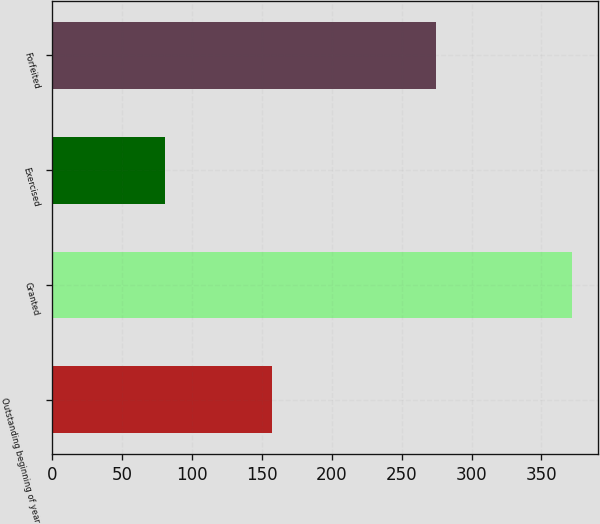Convert chart. <chart><loc_0><loc_0><loc_500><loc_500><bar_chart><fcel>Outstanding beginning of year<fcel>Granted<fcel>Exercised<fcel>Forfeited<nl><fcel>157.07<fcel>371.7<fcel>80.31<fcel>274.25<nl></chart> 